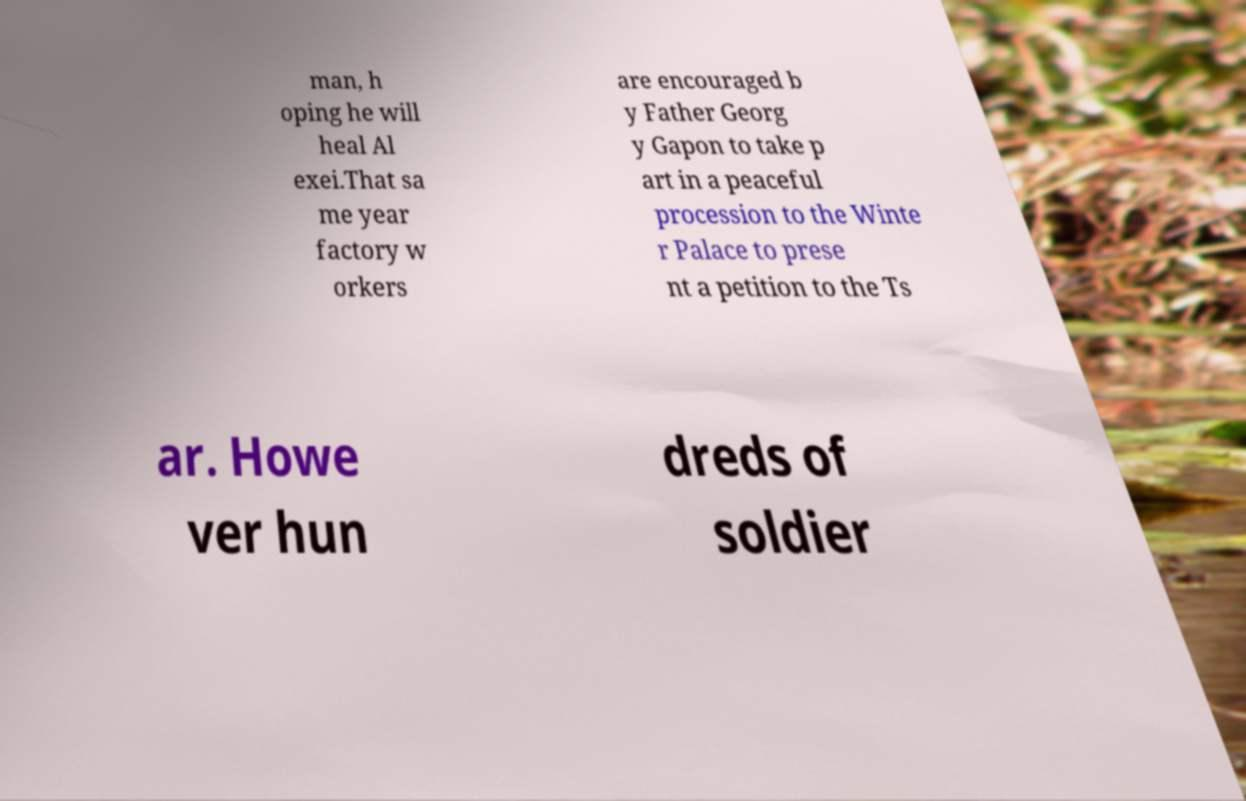There's text embedded in this image that I need extracted. Can you transcribe it verbatim? man, h oping he will heal Al exei.That sa me year factory w orkers are encouraged b y Father Georg y Gapon to take p art in a peaceful procession to the Winte r Palace to prese nt a petition to the Ts ar. Howe ver hun dreds of soldier 